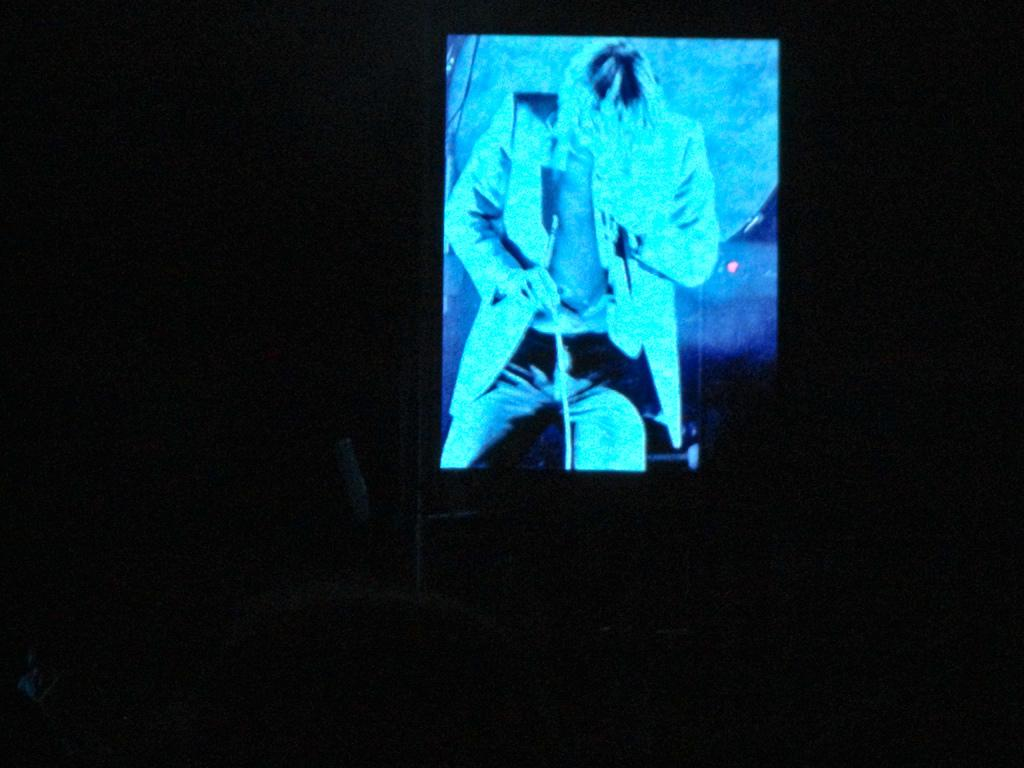What is the main object in the image? There is a projector screen in the image. What can be seen on the projector screen? A man is visible on the screen. Can you describe the man's attire? The man is wearing a suit, trousers, and a watch. What is the man holding in his hand? The man is holding a stick. How would you describe the appearance of the bottom of the screen? The bottom of the screen appears dark. What type of brass instrument is the man playing in the image? There is no brass instrument present in the image; the man is holding a stick. Can you tell me how many airplanes are visible at the airport in the image? There is no airport or airplanes visible in the image; it features a projector screen with a man on it. 